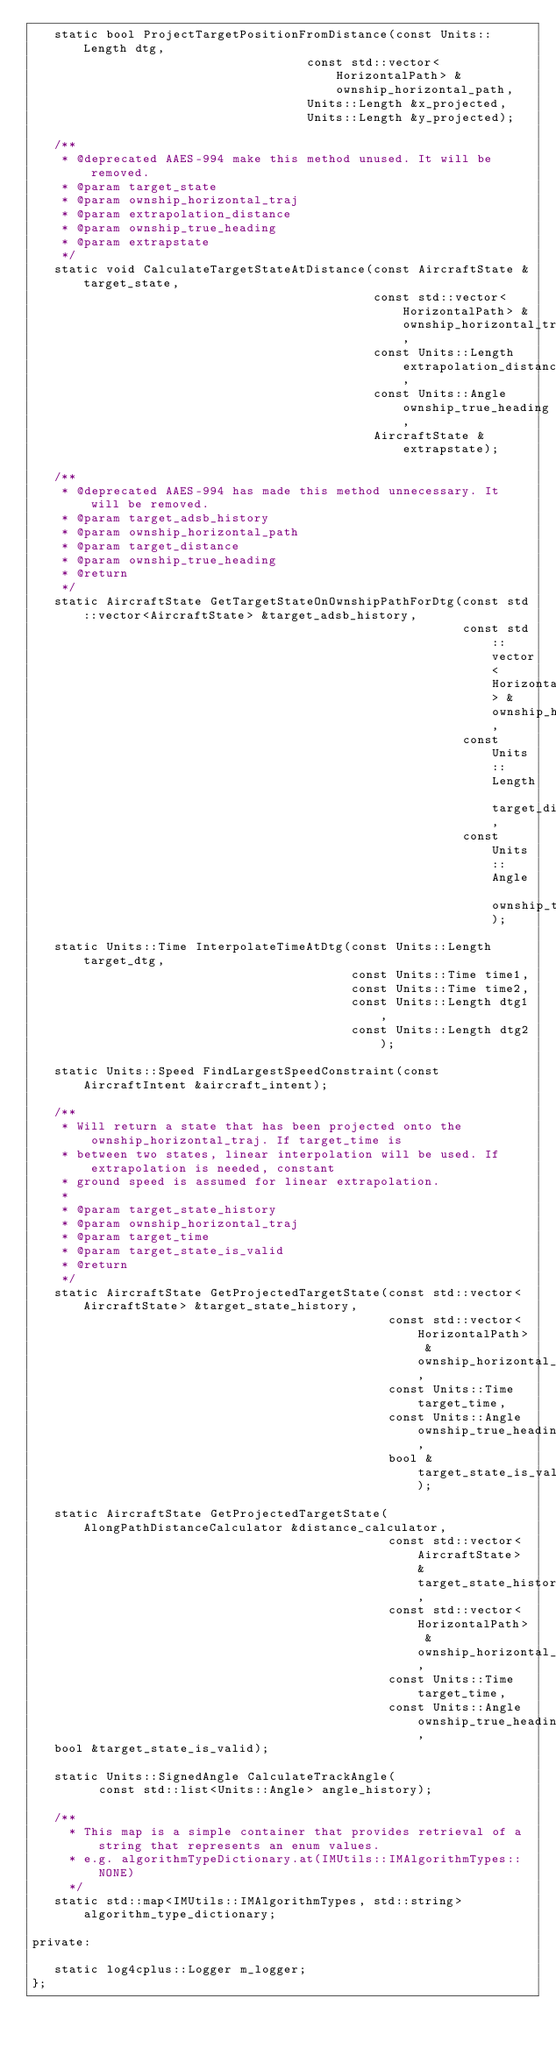Convert code to text. <code><loc_0><loc_0><loc_500><loc_500><_C_>   static bool ProjectTargetPositionFromDistance(const Units::Length dtg,
                                     const std::vector<HorizontalPath> &ownship_horizontal_path,
                                     Units::Length &x_projected,
                                     Units::Length &y_projected);

   /**
    * @deprecated AAES-994 make this method unused. It will be removed.
    * @param target_state
    * @param ownship_horizontal_traj
    * @param extrapolation_distance
    * @param ownship_true_heading
    * @param extrapstate
    */
   static void CalculateTargetStateAtDistance(const AircraftState &target_state,
                                              const std::vector<HorizontalPath> &ownship_horizontal_traj,
                                              const Units::Length extrapolation_distance,
                                              const Units::Angle ownship_true_heading,
                                              AircraftState &extrapstate);

   /**
    * @deprecated AAES-994 has made this method unnecessary. It will be removed.
    * @param target_adsb_history
    * @param ownship_horizontal_path
    * @param target_distance
    * @param ownship_true_heading
    * @return
    */
   static AircraftState GetTargetStateOnOwnshipPathForDtg(const std::vector<AircraftState> &target_adsb_history,
                                                          const std::vector<HorizontalPath> &ownship_horizontal_path,
                                                          const Units::Length target_distance,
                                                          const Units::Angle ownship_true_heading);

   static Units::Time InterpolateTimeAtDtg(const Units::Length target_dtg,
                                           const Units::Time time1,
                                           const Units::Time time2,
                                           const Units::Length dtg1,
                                           const Units::Length dtg2);

   static Units::Speed FindLargestSpeedConstraint(const AircraftIntent &aircraft_intent);

   /**
    * Will return a state that has been projected onto the ownship_horizontal_traj. If target_time is
    * between two states, linear interpolation will be used. If extrapolation is needed, constant
    * ground speed is assumed for linear extrapolation.
    *
    * @param target_state_history
    * @param ownship_horizontal_traj
    * @param target_time
    * @param target_state_is_valid
    * @return
    */
   static AircraftState GetProjectedTargetState(const std::vector<AircraftState> &target_state_history,
                                                const std::vector<HorizontalPath> &ownship_horizontal_traj,
                                                const Units::Time target_time,
                                                const Units::Angle ownship_true_heading,
                                                bool &target_state_is_valid);

   static AircraftState GetProjectedTargetState(AlongPathDistanceCalculator &distance_calculator,
                                                const std::vector<AircraftState> &target_state_history,
                                                const std::vector<HorizontalPath> &ownship_horizontal_traj,
                                                const Units::Time target_time,
                                                const Units::Angle ownship_true_heading,
   bool &target_state_is_valid);

   static Units::SignedAngle CalculateTrackAngle(
         const std::list<Units::Angle> angle_history);

   /**
     * This map is a simple container that provides retrieval of a string that represents an enum values.
     * e.g. algorithmTypeDictionary.at(IMUtils::IMAlgorithmTypes::NONE)
     */
   static std::map<IMUtils::IMAlgorithmTypes, std::string> algorithm_type_dictionary;

private:

   static log4cplus::Logger m_logger;
};
</code> 